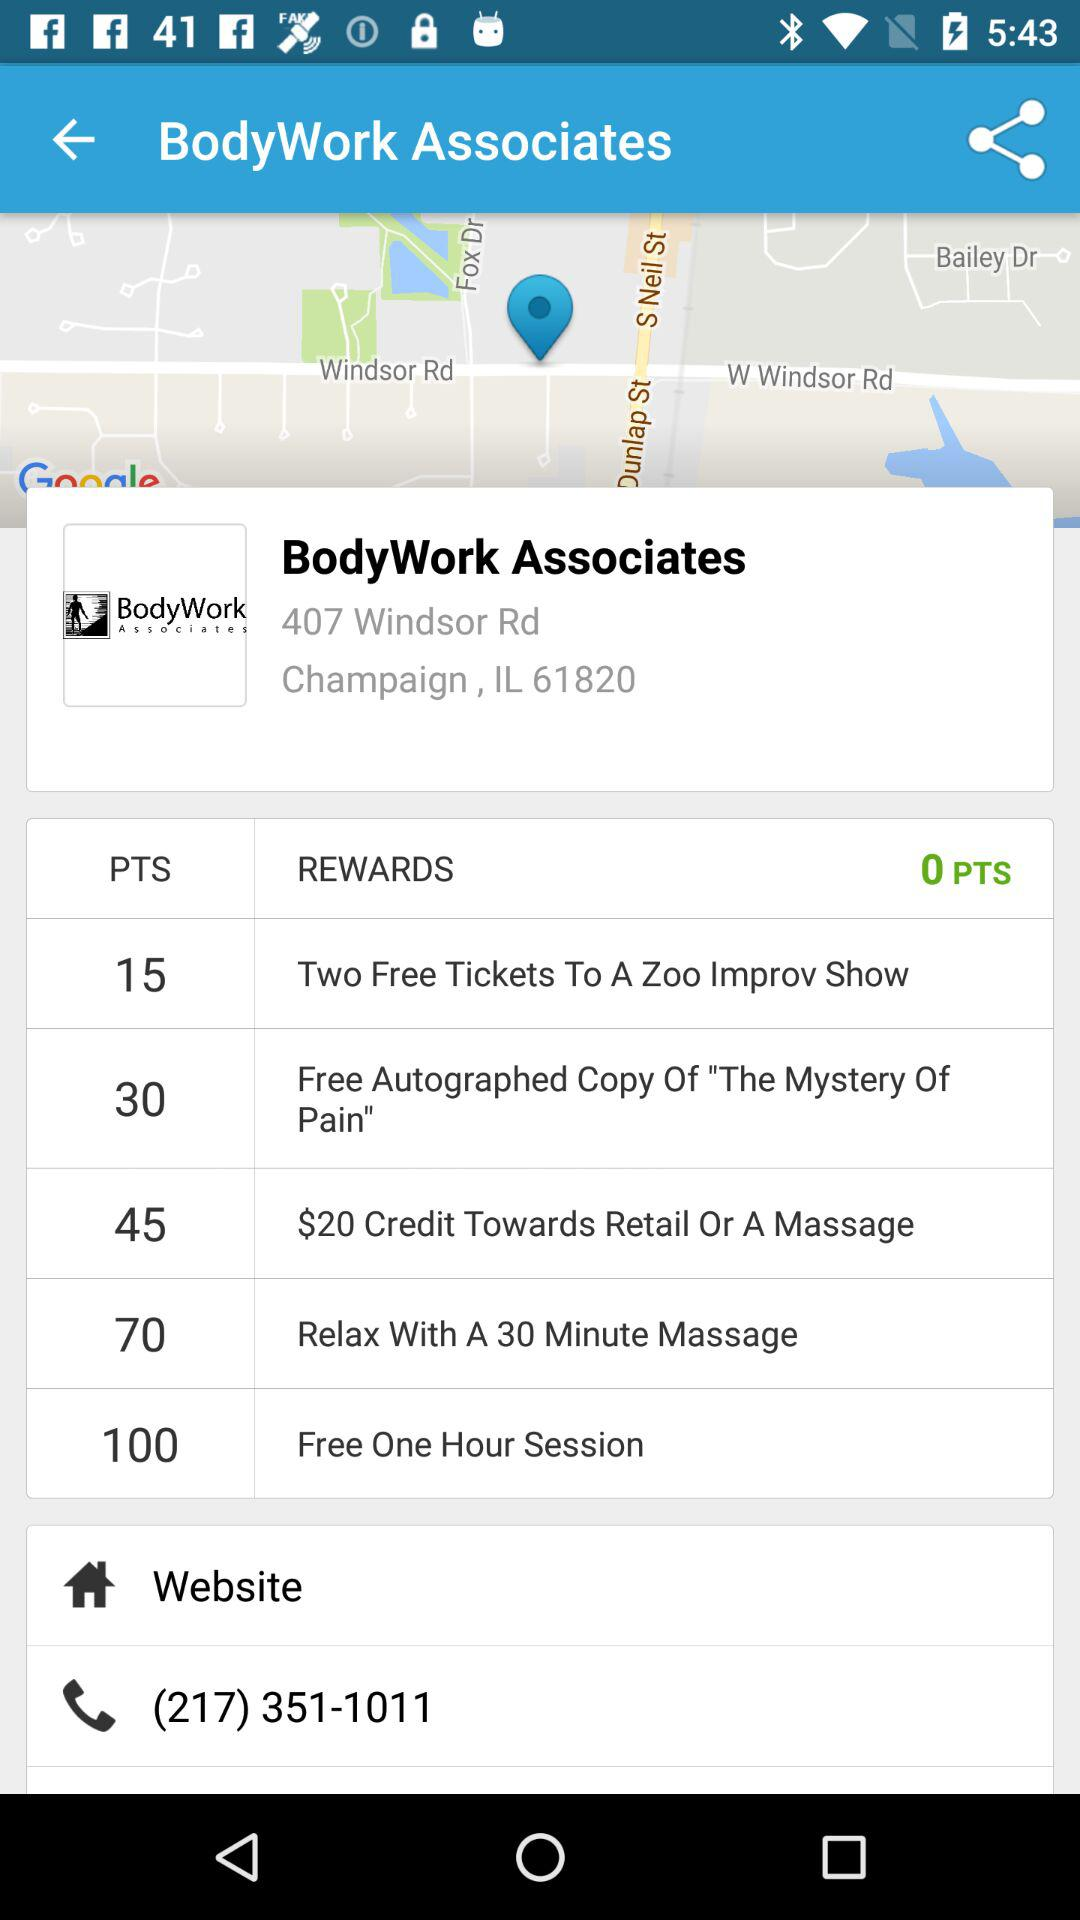How long can we relax while getting a massage? You can relax for 30 minutes while getting a massage. 